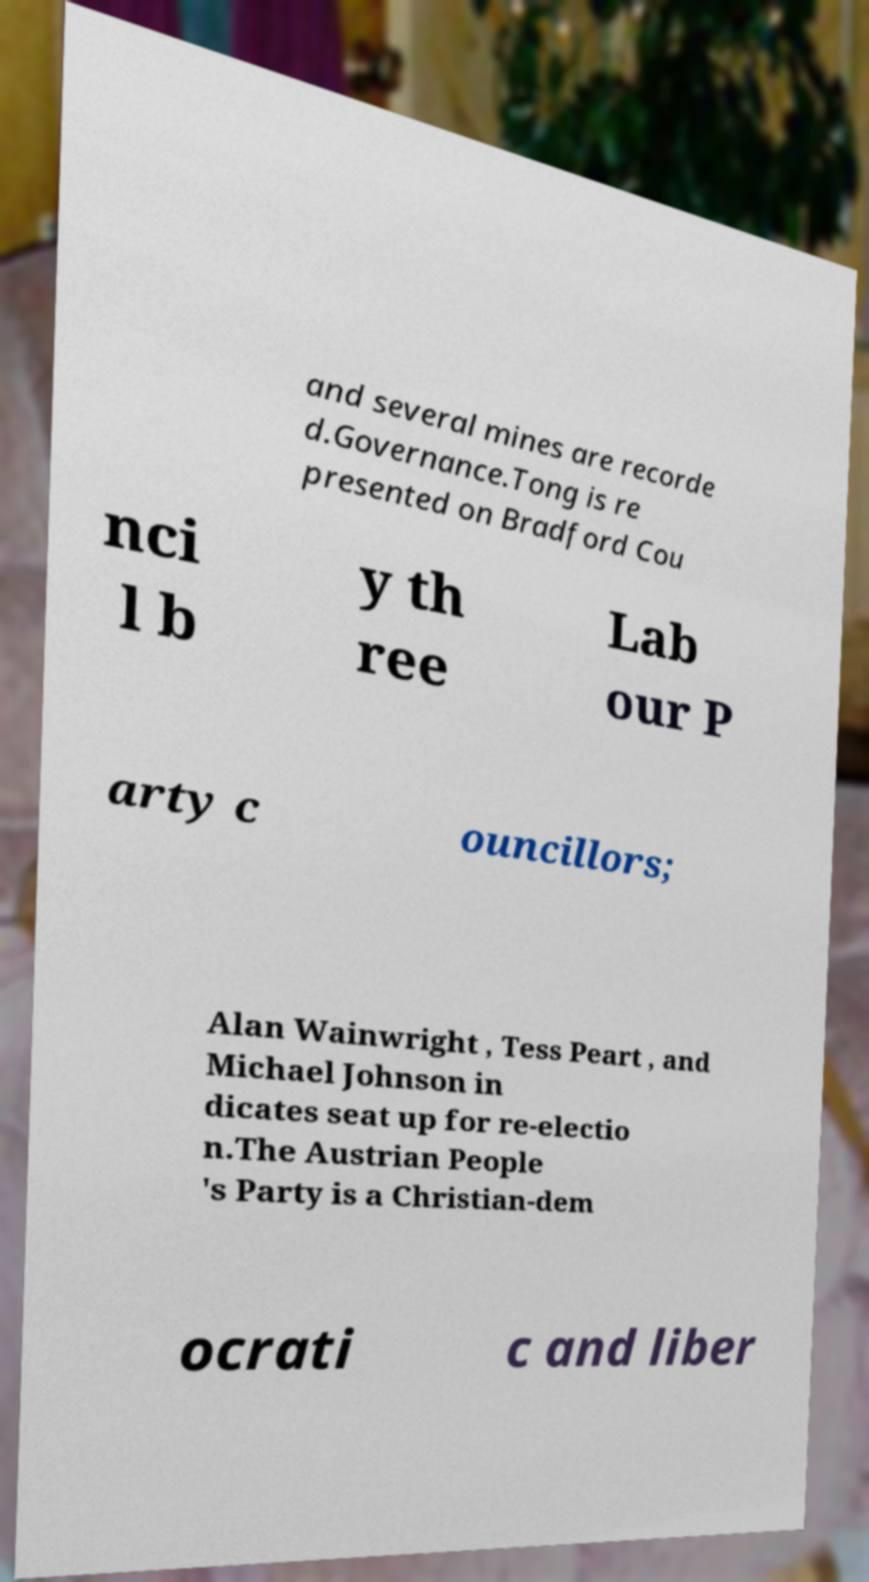Please identify and transcribe the text found in this image. and several mines are recorde d.Governance.Tong is re presented on Bradford Cou nci l b y th ree Lab our P arty c ouncillors; Alan Wainwright , Tess Peart , and Michael Johnson in dicates seat up for re-electio n.The Austrian People 's Party is a Christian-dem ocrati c and liber 